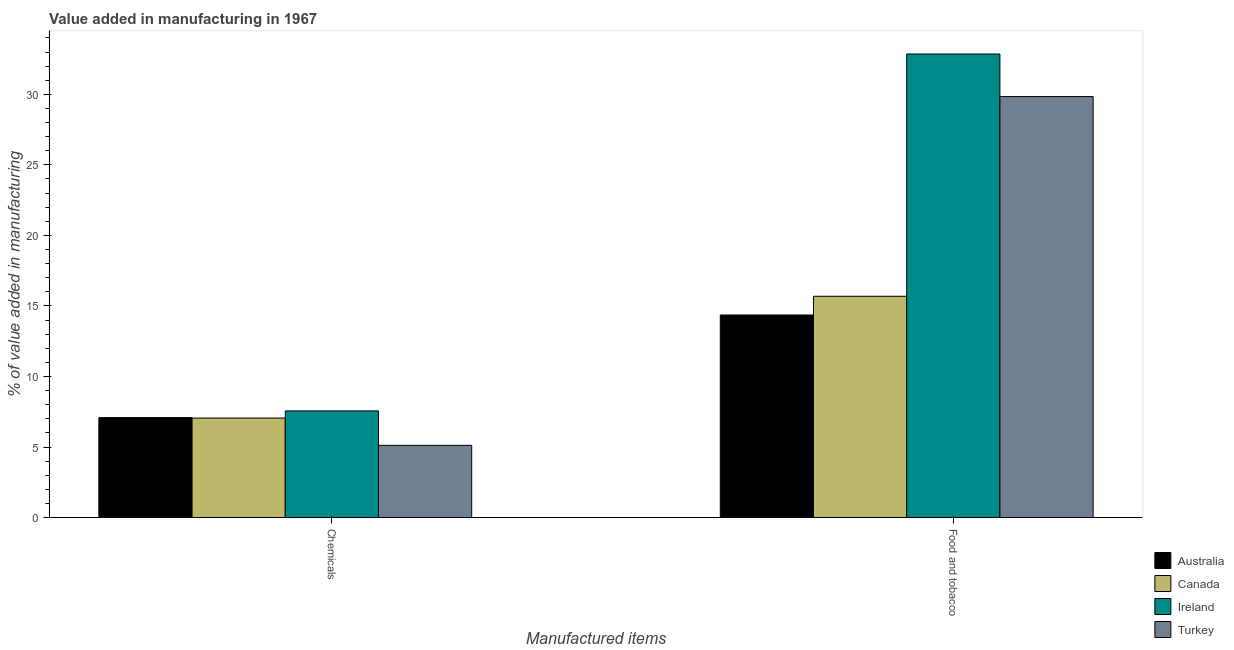How many different coloured bars are there?
Keep it short and to the point. 4. How many groups of bars are there?
Provide a succinct answer. 2. What is the label of the 1st group of bars from the left?
Your answer should be very brief. Chemicals. What is the value added by  manufacturing chemicals in Ireland?
Offer a very short reply. 7.56. Across all countries, what is the maximum value added by manufacturing food and tobacco?
Your answer should be very brief. 32.86. Across all countries, what is the minimum value added by manufacturing food and tobacco?
Provide a short and direct response. 14.36. In which country was the value added by  manufacturing chemicals maximum?
Ensure brevity in your answer.  Ireland. What is the total value added by  manufacturing chemicals in the graph?
Make the answer very short. 26.82. What is the difference between the value added by manufacturing food and tobacco in Turkey and that in Ireland?
Your answer should be compact. -3.02. What is the difference between the value added by manufacturing food and tobacco in Turkey and the value added by  manufacturing chemicals in Australia?
Give a very brief answer. 22.76. What is the average value added by manufacturing food and tobacco per country?
Keep it short and to the point. 23.19. What is the difference between the value added by manufacturing food and tobacco and value added by  manufacturing chemicals in Canada?
Your answer should be very brief. 8.63. What is the ratio of the value added by  manufacturing chemicals in Australia to that in Canada?
Your answer should be very brief. 1. What does the 4th bar from the right in Food and tobacco represents?
Make the answer very short. Australia. Are all the bars in the graph horizontal?
Keep it short and to the point. No. How many countries are there in the graph?
Offer a terse response. 4. Are the values on the major ticks of Y-axis written in scientific E-notation?
Your answer should be very brief. No. Does the graph contain any zero values?
Give a very brief answer. No. Where does the legend appear in the graph?
Give a very brief answer. Bottom right. What is the title of the graph?
Ensure brevity in your answer.  Value added in manufacturing in 1967. Does "China" appear as one of the legend labels in the graph?
Your answer should be compact. No. What is the label or title of the X-axis?
Make the answer very short. Manufactured items. What is the label or title of the Y-axis?
Offer a terse response. % of value added in manufacturing. What is the % of value added in manufacturing in Australia in Chemicals?
Keep it short and to the point. 7.08. What is the % of value added in manufacturing in Canada in Chemicals?
Your answer should be very brief. 7.05. What is the % of value added in manufacturing in Ireland in Chemicals?
Your answer should be very brief. 7.56. What is the % of value added in manufacturing in Turkey in Chemicals?
Your answer should be very brief. 5.12. What is the % of value added in manufacturing of Australia in Food and tobacco?
Ensure brevity in your answer.  14.36. What is the % of value added in manufacturing of Canada in Food and tobacco?
Provide a short and direct response. 15.69. What is the % of value added in manufacturing in Ireland in Food and tobacco?
Ensure brevity in your answer.  32.86. What is the % of value added in manufacturing of Turkey in Food and tobacco?
Your answer should be very brief. 29.84. Across all Manufactured items, what is the maximum % of value added in manufacturing of Australia?
Keep it short and to the point. 14.36. Across all Manufactured items, what is the maximum % of value added in manufacturing in Canada?
Provide a succinct answer. 15.69. Across all Manufactured items, what is the maximum % of value added in manufacturing of Ireland?
Your response must be concise. 32.86. Across all Manufactured items, what is the maximum % of value added in manufacturing of Turkey?
Give a very brief answer. 29.84. Across all Manufactured items, what is the minimum % of value added in manufacturing in Australia?
Provide a short and direct response. 7.08. Across all Manufactured items, what is the minimum % of value added in manufacturing of Canada?
Offer a terse response. 7.05. Across all Manufactured items, what is the minimum % of value added in manufacturing of Ireland?
Offer a very short reply. 7.56. Across all Manufactured items, what is the minimum % of value added in manufacturing of Turkey?
Your answer should be compact. 5.12. What is the total % of value added in manufacturing of Australia in the graph?
Your answer should be compact. 21.44. What is the total % of value added in manufacturing of Canada in the graph?
Your response must be concise. 22.74. What is the total % of value added in manufacturing in Ireland in the graph?
Make the answer very short. 40.42. What is the total % of value added in manufacturing in Turkey in the graph?
Make the answer very short. 34.96. What is the difference between the % of value added in manufacturing in Australia in Chemicals and that in Food and tobacco?
Your answer should be very brief. -7.27. What is the difference between the % of value added in manufacturing in Canada in Chemicals and that in Food and tobacco?
Offer a very short reply. -8.63. What is the difference between the % of value added in manufacturing of Ireland in Chemicals and that in Food and tobacco?
Provide a succinct answer. -25.3. What is the difference between the % of value added in manufacturing in Turkey in Chemicals and that in Food and tobacco?
Your response must be concise. -24.72. What is the difference between the % of value added in manufacturing in Australia in Chemicals and the % of value added in manufacturing in Canada in Food and tobacco?
Provide a succinct answer. -8.6. What is the difference between the % of value added in manufacturing of Australia in Chemicals and the % of value added in manufacturing of Ireland in Food and tobacco?
Ensure brevity in your answer.  -25.78. What is the difference between the % of value added in manufacturing of Australia in Chemicals and the % of value added in manufacturing of Turkey in Food and tobacco?
Your answer should be compact. -22.76. What is the difference between the % of value added in manufacturing of Canada in Chemicals and the % of value added in manufacturing of Ireland in Food and tobacco?
Make the answer very short. -25.81. What is the difference between the % of value added in manufacturing in Canada in Chemicals and the % of value added in manufacturing in Turkey in Food and tobacco?
Ensure brevity in your answer.  -22.79. What is the difference between the % of value added in manufacturing in Ireland in Chemicals and the % of value added in manufacturing in Turkey in Food and tobacco?
Ensure brevity in your answer.  -22.28. What is the average % of value added in manufacturing of Australia per Manufactured items?
Provide a short and direct response. 10.72. What is the average % of value added in manufacturing in Canada per Manufactured items?
Ensure brevity in your answer.  11.37. What is the average % of value added in manufacturing in Ireland per Manufactured items?
Your answer should be very brief. 20.21. What is the average % of value added in manufacturing in Turkey per Manufactured items?
Ensure brevity in your answer.  17.48. What is the difference between the % of value added in manufacturing in Australia and % of value added in manufacturing in Canada in Chemicals?
Your response must be concise. 0.03. What is the difference between the % of value added in manufacturing in Australia and % of value added in manufacturing in Ireland in Chemicals?
Ensure brevity in your answer.  -0.48. What is the difference between the % of value added in manufacturing in Australia and % of value added in manufacturing in Turkey in Chemicals?
Offer a terse response. 1.96. What is the difference between the % of value added in manufacturing in Canada and % of value added in manufacturing in Ireland in Chemicals?
Your answer should be very brief. -0.51. What is the difference between the % of value added in manufacturing in Canada and % of value added in manufacturing in Turkey in Chemicals?
Give a very brief answer. 1.93. What is the difference between the % of value added in manufacturing of Ireland and % of value added in manufacturing of Turkey in Chemicals?
Your answer should be very brief. 2.44. What is the difference between the % of value added in manufacturing of Australia and % of value added in manufacturing of Canada in Food and tobacco?
Give a very brief answer. -1.33. What is the difference between the % of value added in manufacturing in Australia and % of value added in manufacturing in Ireland in Food and tobacco?
Make the answer very short. -18.5. What is the difference between the % of value added in manufacturing in Australia and % of value added in manufacturing in Turkey in Food and tobacco?
Provide a short and direct response. -15.48. What is the difference between the % of value added in manufacturing in Canada and % of value added in manufacturing in Ireland in Food and tobacco?
Give a very brief answer. -17.17. What is the difference between the % of value added in manufacturing in Canada and % of value added in manufacturing in Turkey in Food and tobacco?
Keep it short and to the point. -14.16. What is the difference between the % of value added in manufacturing in Ireland and % of value added in manufacturing in Turkey in Food and tobacco?
Make the answer very short. 3.02. What is the ratio of the % of value added in manufacturing of Australia in Chemicals to that in Food and tobacco?
Keep it short and to the point. 0.49. What is the ratio of the % of value added in manufacturing in Canada in Chemicals to that in Food and tobacco?
Your answer should be compact. 0.45. What is the ratio of the % of value added in manufacturing in Ireland in Chemicals to that in Food and tobacco?
Your answer should be compact. 0.23. What is the ratio of the % of value added in manufacturing in Turkey in Chemicals to that in Food and tobacco?
Give a very brief answer. 0.17. What is the difference between the highest and the second highest % of value added in manufacturing of Australia?
Your answer should be very brief. 7.27. What is the difference between the highest and the second highest % of value added in manufacturing of Canada?
Give a very brief answer. 8.63. What is the difference between the highest and the second highest % of value added in manufacturing of Ireland?
Offer a terse response. 25.3. What is the difference between the highest and the second highest % of value added in manufacturing in Turkey?
Ensure brevity in your answer.  24.72. What is the difference between the highest and the lowest % of value added in manufacturing in Australia?
Your response must be concise. 7.27. What is the difference between the highest and the lowest % of value added in manufacturing of Canada?
Offer a terse response. 8.63. What is the difference between the highest and the lowest % of value added in manufacturing of Ireland?
Ensure brevity in your answer.  25.3. What is the difference between the highest and the lowest % of value added in manufacturing of Turkey?
Your answer should be very brief. 24.72. 